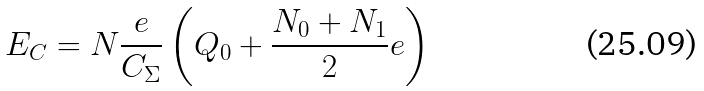Convert formula to latex. <formula><loc_0><loc_0><loc_500><loc_500>E _ { C } = N \frac { e } { C _ { \Sigma } } \left ( Q _ { 0 } + \frac { N _ { 0 } + N _ { 1 } } { 2 } e \right )</formula> 